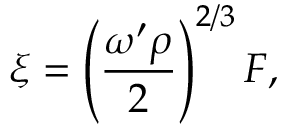<formula> <loc_0><loc_0><loc_500><loc_500>\xi = \left ( \frac { \omega ^ { \prime } \rho } { 2 } \right ) ^ { 2 / 3 } F ,</formula> 